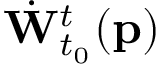<formula> <loc_0><loc_0><loc_500><loc_500>\dot { W } _ { t _ { 0 } } ^ { t } ( p )</formula> 